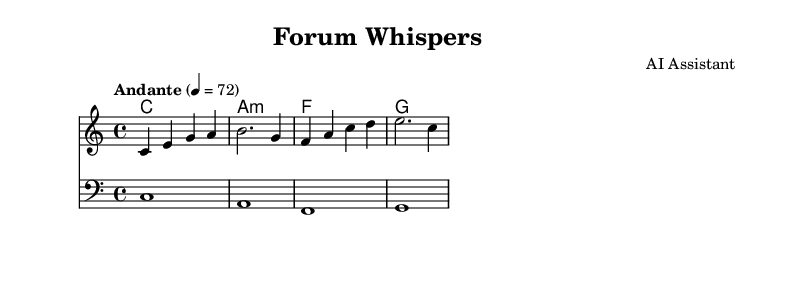What is the key signature of this music? The key signature indicated in the music sheet is C major, which is identified by the absence of any sharps or flats.
Answer: C major What is the time signature of this music? The time signature is listed as 4/4, meaning there are four beats in each measure and a quarter note gets one beat.
Answer: 4/4 What is the tempo marking for this piece? The tempo marking is "Andante," which indicates a moderately slow pace, typically between 76 to 108 beats per minute. Here, it is specifically set to 72 beats per minute.
Answer: Andante How many measures are in the melody section? The melody section has a total of four measures, as counted by the four distinct lines of music notation present.
Answer: 4 What type of music is represented by this sheet? The sheet music is characterized as soothing ambient music, which is suitable for background use during discussions. This is indicated by the gentle tempo and harmonic progressions.
Answer: Ambient music What are the first notes played in the melody? The initial notes in the melody are C, E, G, and A, which establish a soft and calming sound at the beginning of the piece.
Answer: C, E, G, A What chord does the first measure represent? The first measure represents a C major chord, as indicated in the chord names section, which includes the root note C and is played for the entire measure.
Answer: C major 